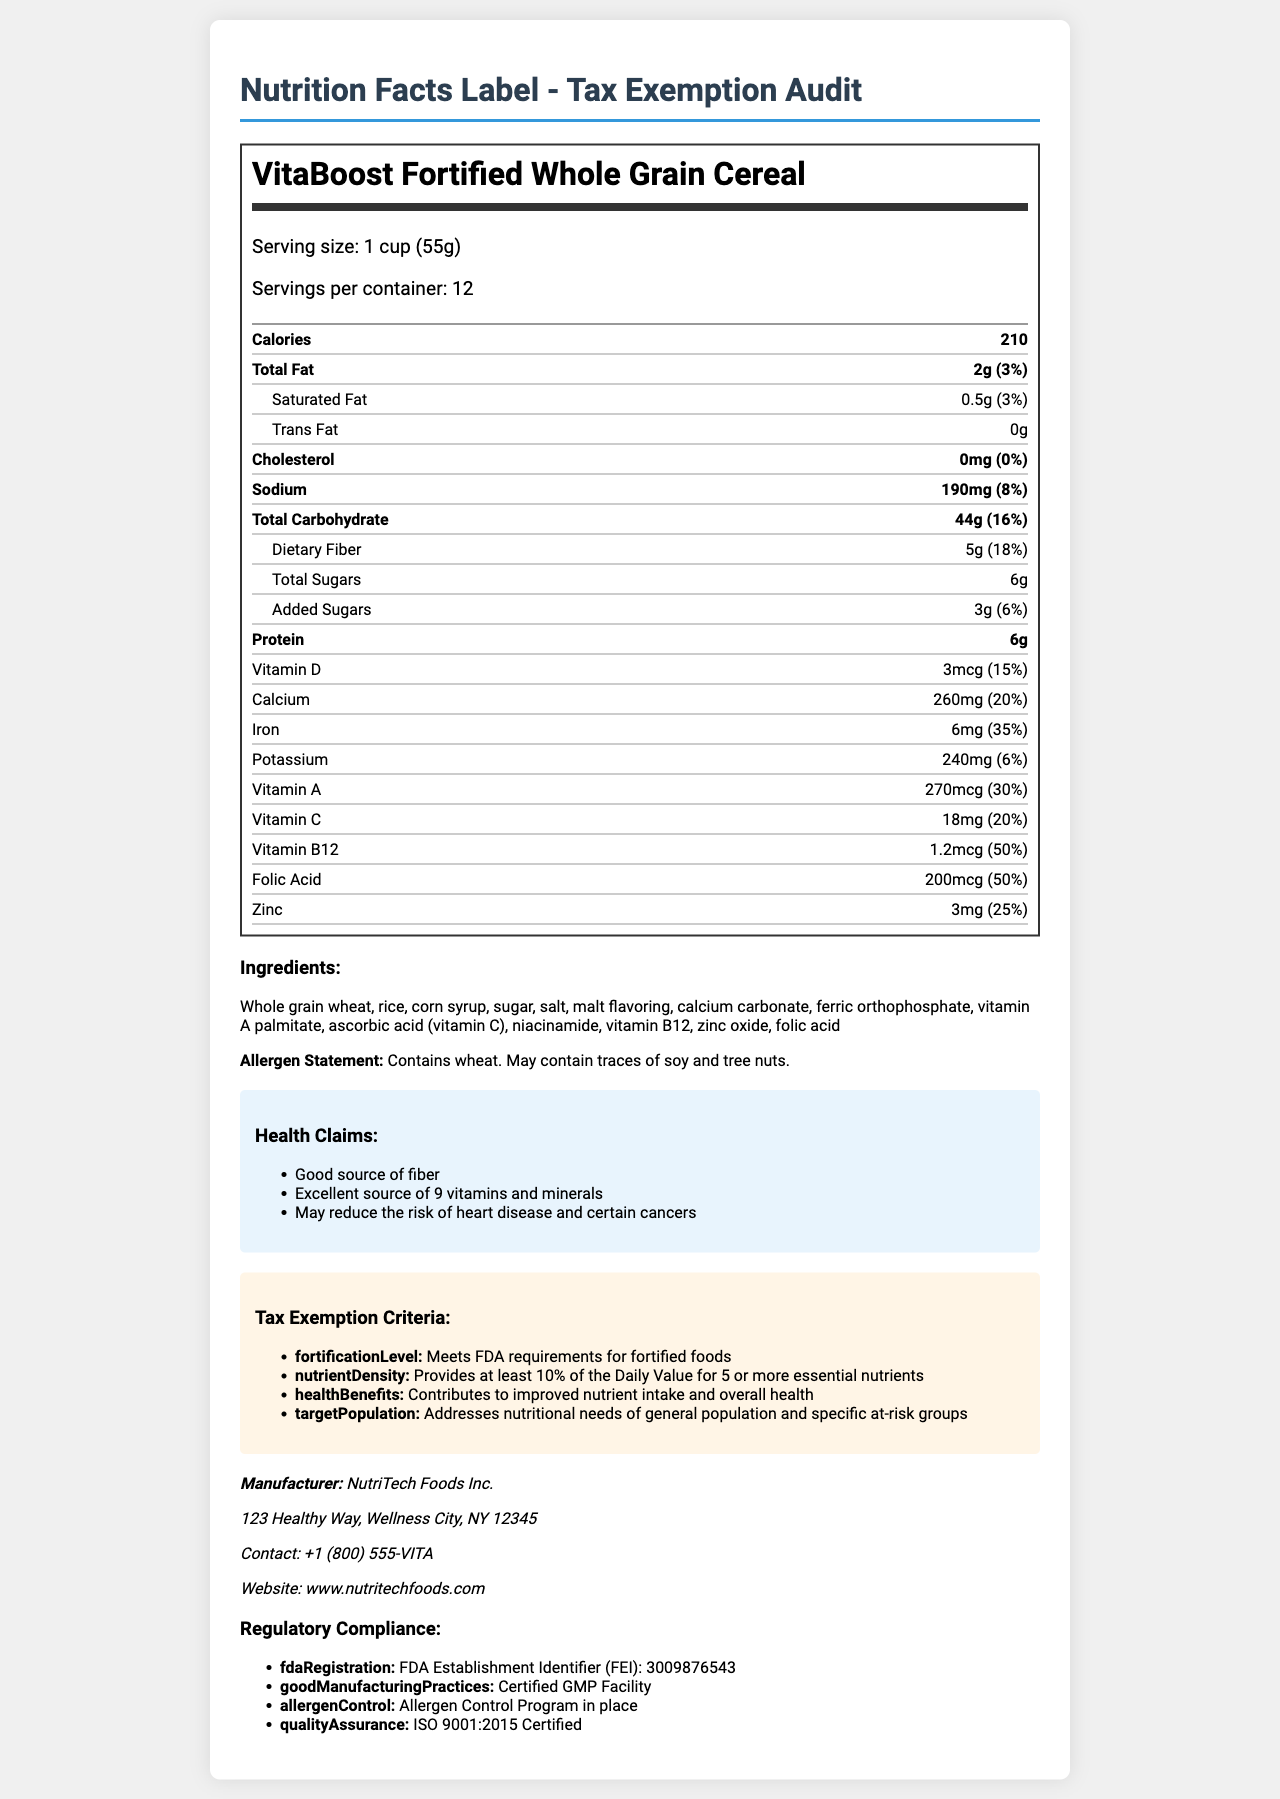what is the serving size? The document lists the serving size as "1 cup (55g)" for VitaBoost Fortified Whole Grain Cereal.
Answer: 1 cup (55g) how many servings are in the container? The document states that there are 12 servings per container.
Answer: 12 how many calories are there per serving? The document indicates that there are 210 calories per serving.
Answer: 210 calories what is the amount of dietary fiber per serving? The document states that each serving contains 5g of dietary fiber.
Answer: 5g what is the percentage daily value of Vitamin C? The document mentions that the percentage daily value of Vitamin C is 20%.
Answer: 20% which ingredient is listed first on the ingredients list? The first ingredient listed is "Whole grain wheat".
Answer: Whole grain wheat how many grams of protein are there per serving? The document lists 6g of protein per serving.
Answer: 6g what percentage of daily value of calcium does one serving provide? The document states that one serving provides 20% of the daily value of calcium.
Answer: 20% which health condition might this product help reduce the risk of? A. Diabetes B. Heart Disease C. Obesity One of the health claims states it "May reduce the risk of heart disease and certain cancers."
Answer: B. Heart Disease how many added sugars are in one serving? The document indicates that there are 3g of added sugars per serving.
Answer: 3g does the product contain wheat? The allergen statement in the document clearly states "Contains wheat."
Answer: Yes describe the entire document. The document provides comprehensive information about the fortified cereal's nutritional profile, including the amounts and daily values of various nutrients, the ingredients used, potential allergens, health benefits, and the criteria it meets for tax exemption. It also includes the manufacturer's contact information and regulatory certifications.
Answer: The document is a nutrition facts label for VitaBoost Fortified Whole Grain Cereal, detailing the serving size, nutritional content, ingredients, allergen information, health claims, tax exemption criteria, manufacturer details, and regulatory compliance information. what is the total weight of the cereal in the container? The weight of each serving is provided (55g), and the number of servings (12) is given, but the total weight isn’t directly stated.
Answer: Not enough information 